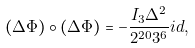<formula> <loc_0><loc_0><loc_500><loc_500>( \Delta \Phi ) \circ ( \Delta \Phi ) = - \frac { I _ { 3 } \Delta ^ { 2 } } { 2 ^ { 2 0 } 3 ^ { 6 } } { i d } ,</formula> 